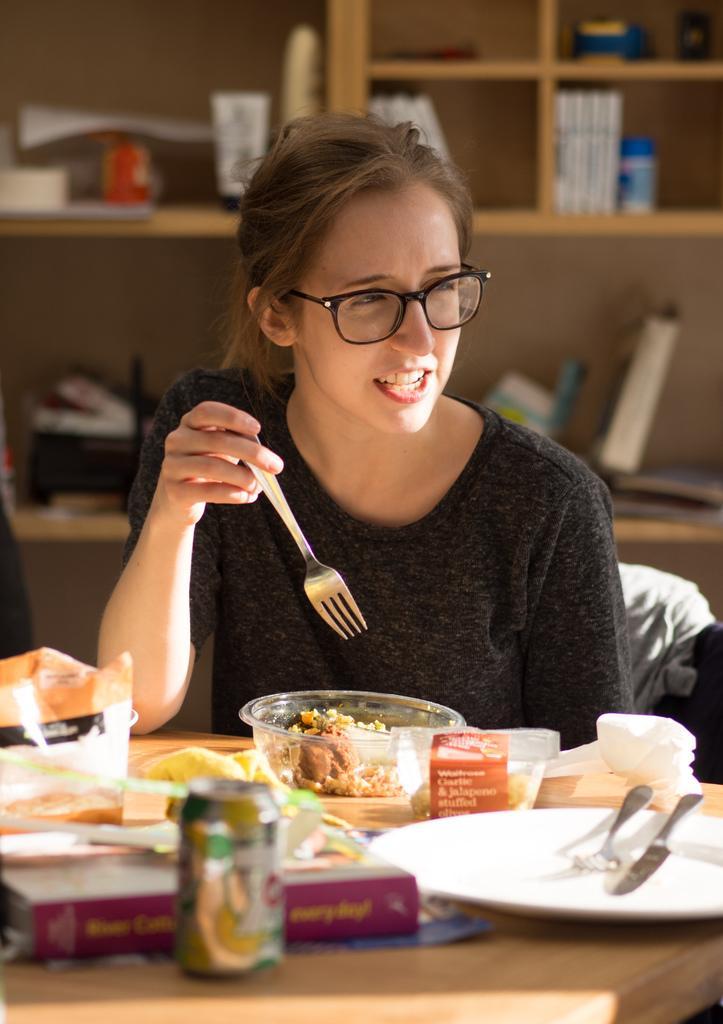Could you give a brief overview of what you see in this image? In this image the woman is sitting on the chair. On the table there is a bowl,food,fork,plate,tissues. At the back side there is a racks. 